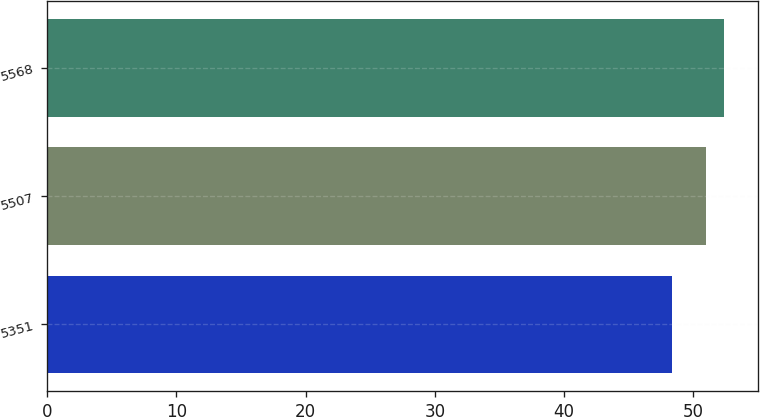Convert chart to OTSL. <chart><loc_0><loc_0><loc_500><loc_500><bar_chart><fcel>5351<fcel>5507<fcel>5568<nl><fcel>48.37<fcel>50.97<fcel>52.37<nl></chart> 